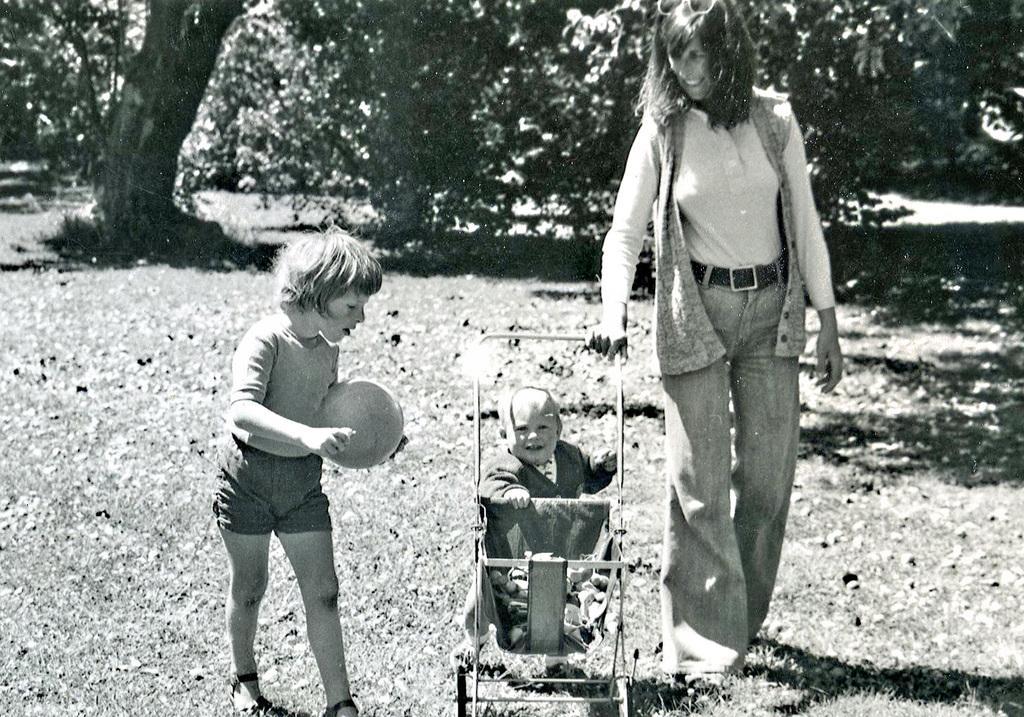Could you give a brief overview of what you see in this image? On the right side of the image we can see a lady standing and holding a trolley. On the left there is a boy walking and holding a ball in his hand. In the center we can see a baby sitting in the trolley. In the background there are trees. 